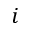Convert formula to latex. <formula><loc_0><loc_0><loc_500><loc_500>i</formula> 